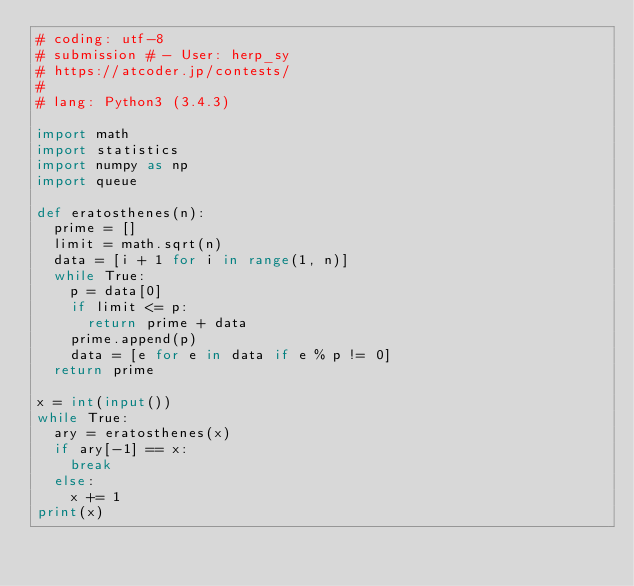Convert code to text. <code><loc_0><loc_0><loc_500><loc_500><_Python_># coding: utf-8
# submission # - User: herp_sy
# https://atcoder.jp/contests/
#
# lang: Python3 (3.4.3)

import math
import statistics
import numpy as np
import queue

def eratosthenes(n):
  prime = []
  limit = math.sqrt(n)
  data = [i + 1 for i in range(1, n)]
  while True:
    p = data[0]
    if limit <= p:
      return prime + data
    prime.append(p)
    data = [e for e in data if e % p != 0]
  return prime

x = int(input())
while True:
  ary = eratosthenes(x)
  if ary[-1] == x:
    break
  else:
    x += 1
print(x)
</code> 